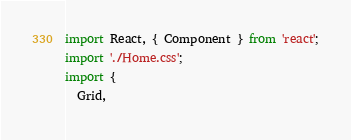<code> <loc_0><loc_0><loc_500><loc_500><_JavaScript_>import React, { Component } from 'react';
import './Home.css';
import {
  Grid,</code> 